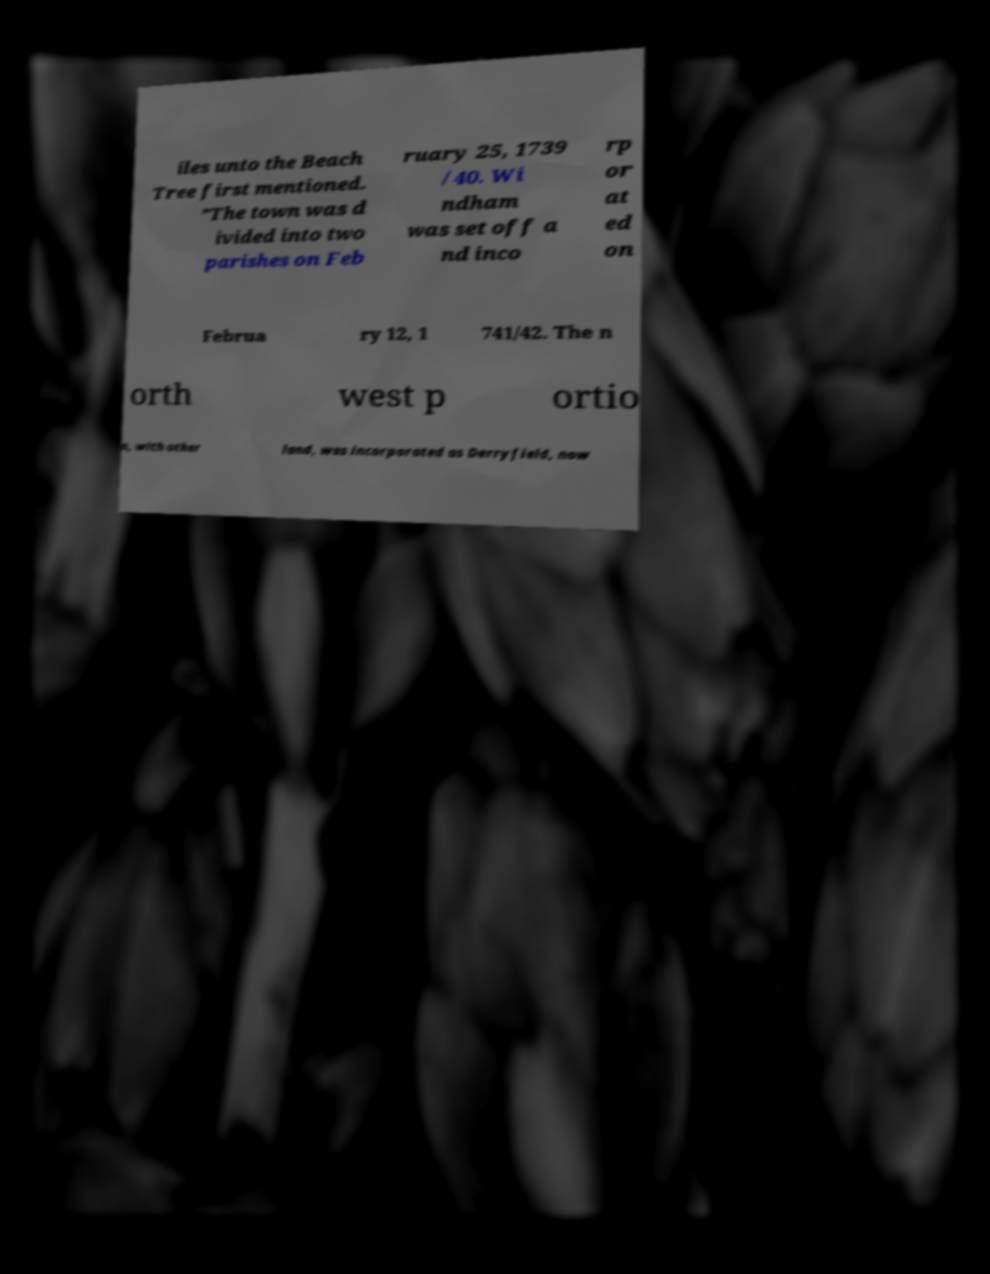Please read and relay the text visible in this image. What does it say? iles unto the Beach Tree first mentioned. ”The town was d ivided into two parishes on Feb ruary 25, 1739 /40. Wi ndham was set off a nd inco rp or at ed on Februa ry 12, 1 741/42. The n orth west p ortio n, with other land, was incorporated as Derryfield, now 